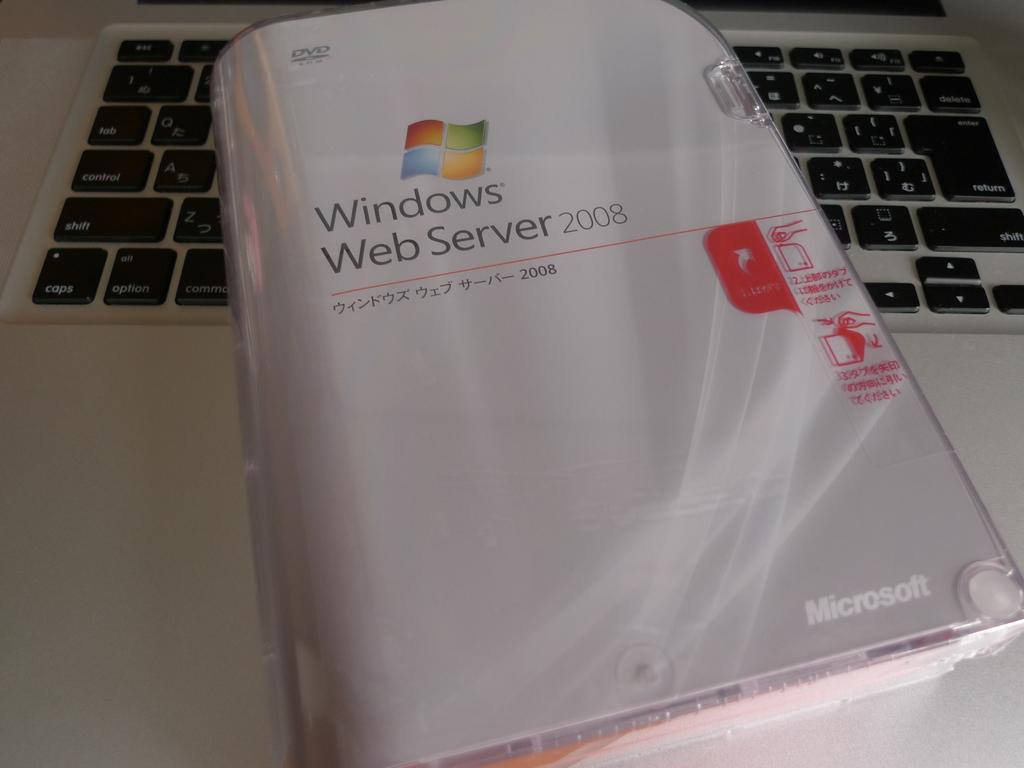Provide a one-sentence caption for the provided image. The Windows Web Server 2008 manual also includes a DVD. 